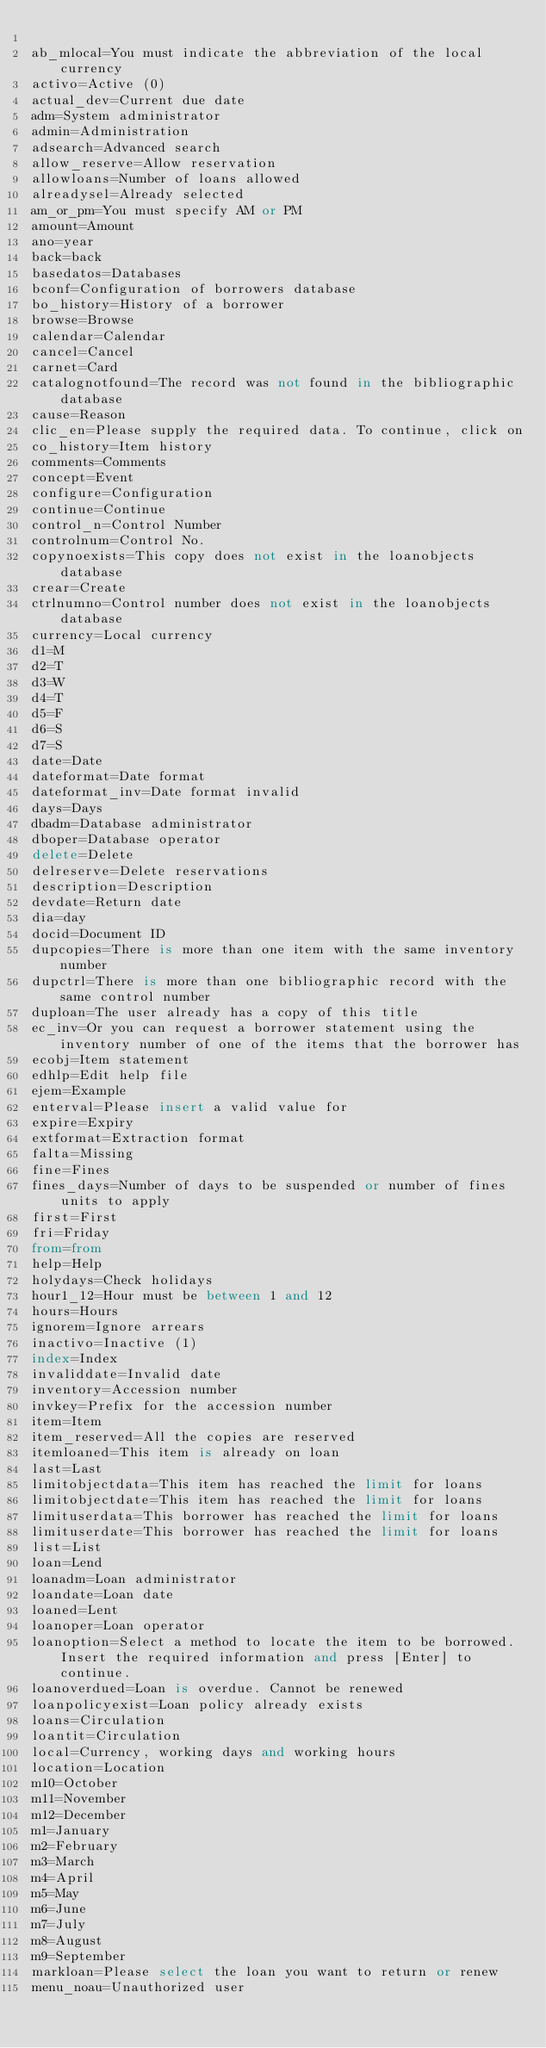<code> <loc_0><loc_0><loc_500><loc_500><_SQL_>
ab_mlocal=You must indicate the abbreviation of the local currency
activo=Active (0)
actual_dev=Current due date
adm=System administrator
admin=Administration
adsearch=Advanced search
allow_reserve=Allow reservation
allowloans=Number of loans allowed
alreadysel=Already selected
am_or_pm=You must specify AM or PM
amount=Amount
ano=year
back=back
basedatos=Databases
bconf=Configuration of borrowers database
bo_history=History of a borrower
browse=Browse
calendar=Calendar
cancel=Cancel
carnet=Card
catalognotfound=The record was not found in the bibliographic database
cause=Reason
clic_en=Please supply the required data. To continue, click on
co_history=Item history
comments=Comments
concept=Event
configure=Configuration
continue=Continue
control_n=Control Number
controlnum=Control No.
copynoexists=This copy does not exist in the loanobjects database
crear=Create
ctrlnumno=Control number does not exist in the loanobjects database
currency=Local currency
d1=M
d2=T
d3=W
d4=T
d5=F
d6=S
d7=S
date=Date
dateformat=Date format
dateformat_inv=Date format invalid
days=Days
dbadm=Database administrator
dboper=Database operator
delete=Delete
delreserve=Delete reservations
description=Description
devdate=Return date
dia=day
docid=Document ID
dupcopies=There is more than one item with the same inventory number
dupctrl=There is more than one bibliographic record with the same control number
duploan=The user already has a copy of this title
ec_inv=Or you can request a borrower statement using the inventory number of one of the items that the borrower has
ecobj=Item statement
edhlp=Edit help file
ejem=Example
enterval=Please insert a valid value for
expire=Expiry
extformat=Extraction format
falta=Missing
fine=Fines
fines_days=Number of days to be suspended or number of fines units to apply
first=First
fri=Friday
from=from
help=Help
holydays=Check holidays
hour1_12=Hour must be between 1 and 12
hours=Hours
ignorem=Ignore arrears
inactivo=Inactive (1)
index=Index
invaliddate=Invalid date
inventory=Accession number
invkey=Prefix for the accession number
item=Item
item_reserved=All the copies are reserved
itemloaned=This item is already on loan
last=Last
limitobjectdata=This item has reached the limit for loans
limitobjectdate=This item has reached the limit for loans
limituserdata=This borrower has reached the limit for loans
limituserdate=This borrower has reached the limit for loans
list=List
loan=Lend
loanadm=Loan administrator
loandate=Loan date
loaned=Lent
loanoper=Loan operator
loanoption=Select a method to locate the item to be borrowed. Insert the required information and press [Enter] to continue.
loanoverdued=Loan is overdue. Cannot be renewed
loanpolicyexist=Loan policy already exists
loans=Circulation
loantit=Circulation
local=Currency, working days and working hours
location=Location
m10=October
m11=November
m12=December
m1=January
m2=February
m3=March
m4=April
m5=May
m6=June
m7=July
m8=August
m9=September
markloan=Please select the loan you want to return or renew
menu_noau=Unauthorized user</code> 